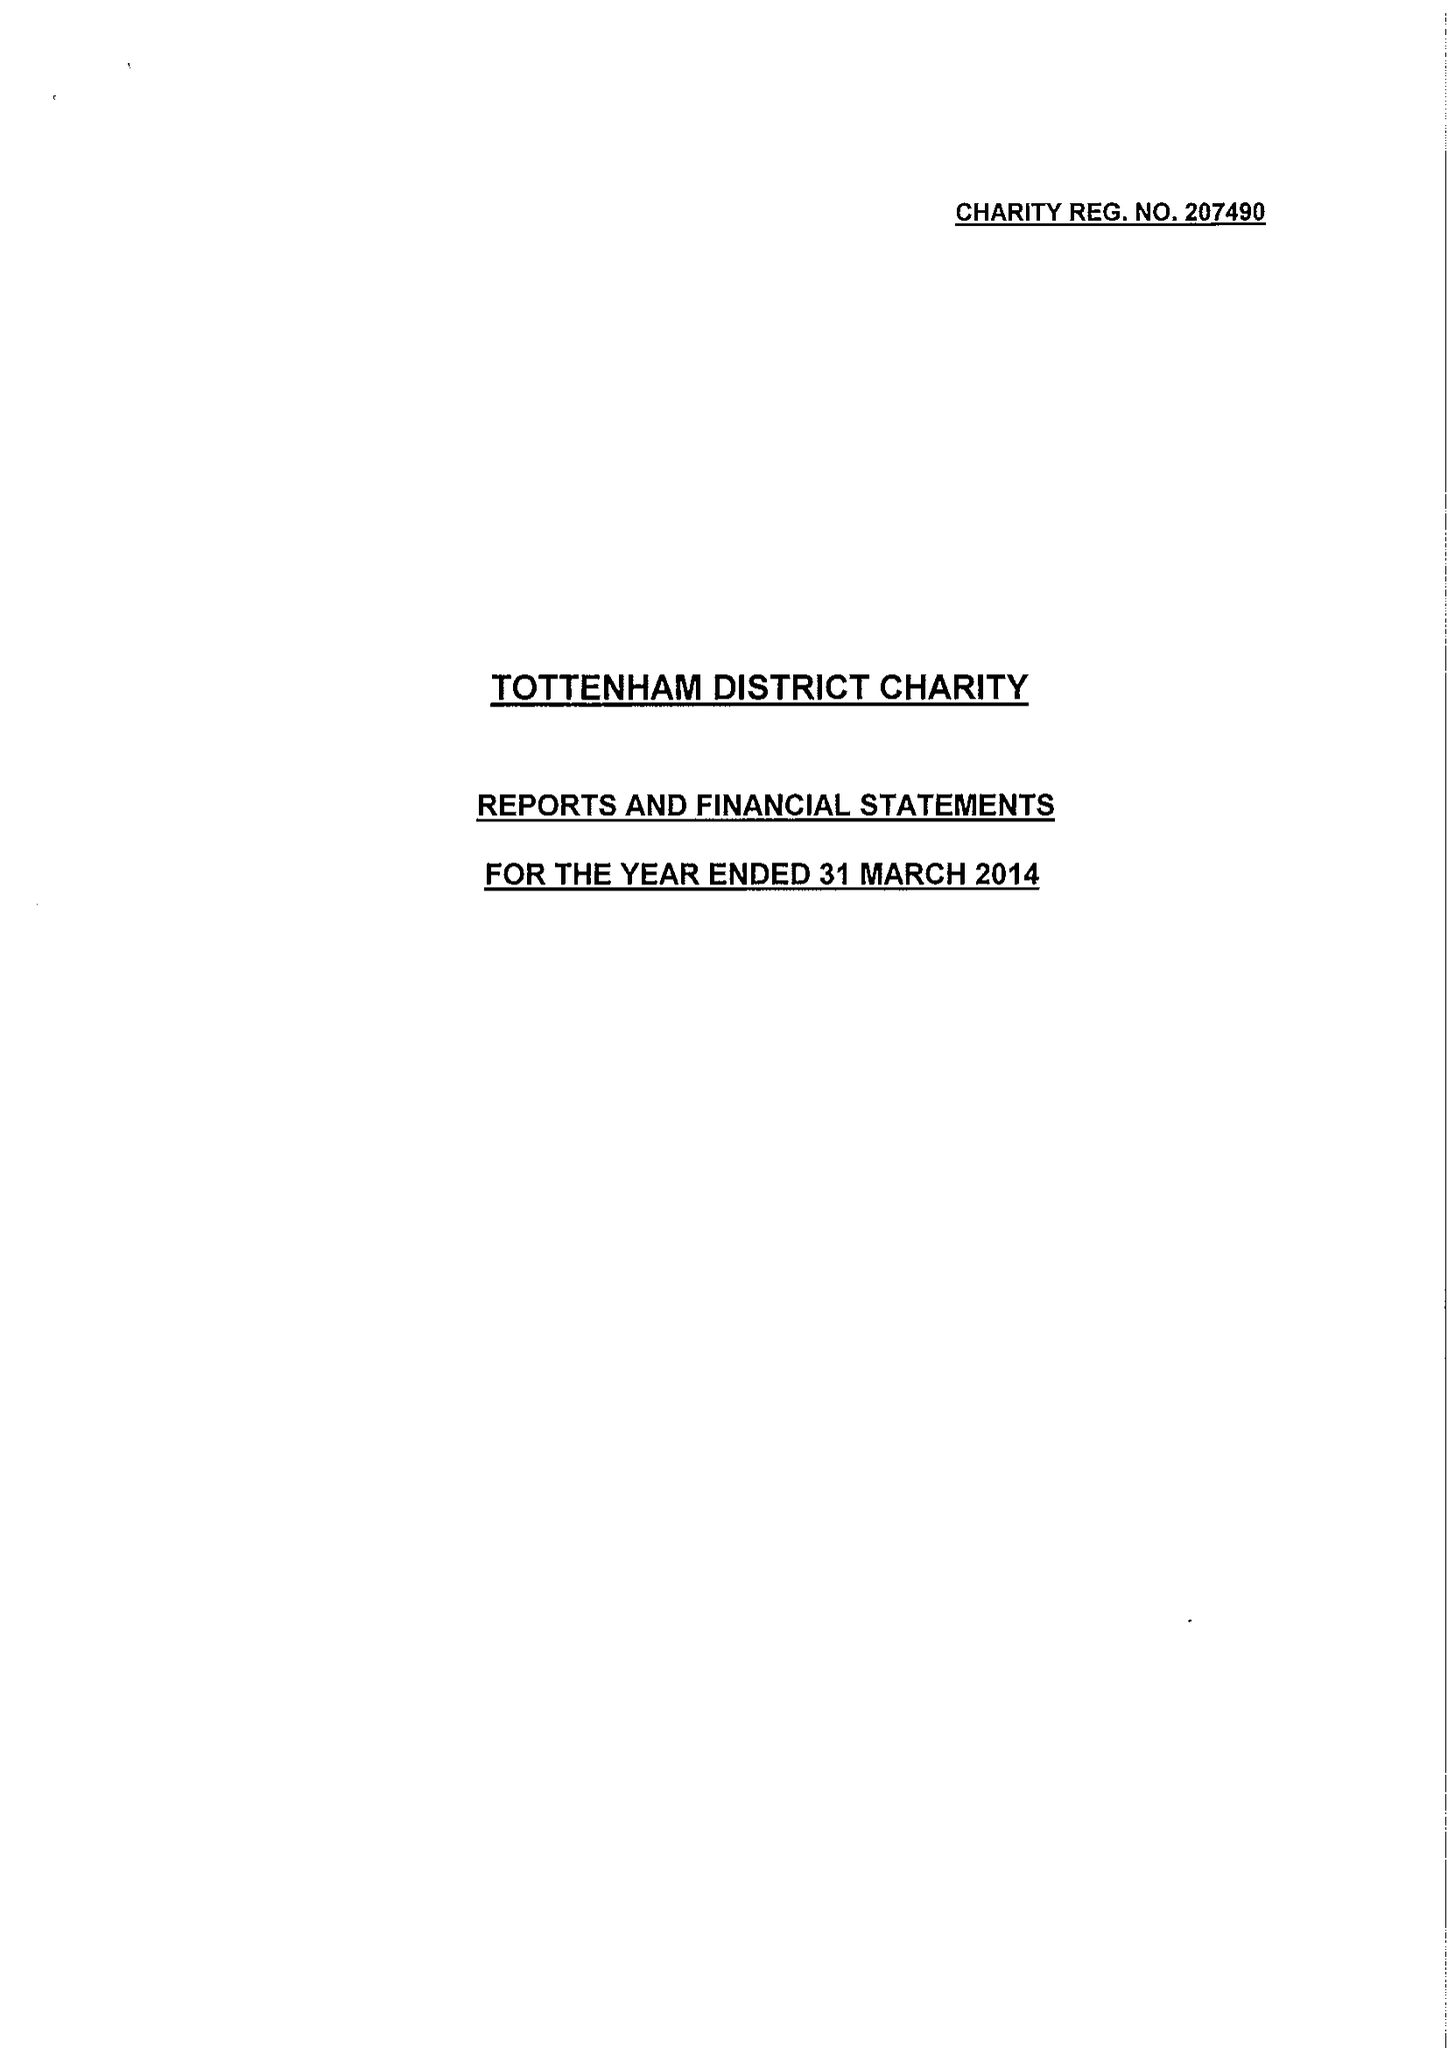What is the value for the income_annually_in_british_pounds?
Answer the question using a single word or phrase. 124349.00 